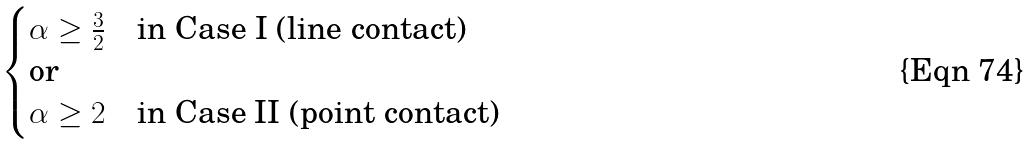Convert formula to latex. <formula><loc_0><loc_0><loc_500><loc_500>\begin{cases} \alpha \geq \frac { 3 } { 2 } \quad \text {in Case I (line contact)} \\ \text {or} \\ \alpha \geq 2 \quad \text {in Case II (point contact)} \end{cases}</formula> 